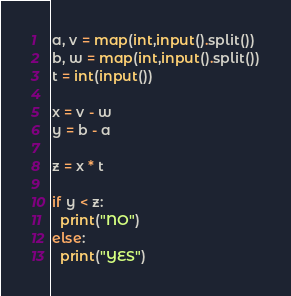<code> <loc_0><loc_0><loc_500><loc_500><_Python_>a, v = map(int,input().split())
b, w = map(int,input().split())
t = int(input())

x = v - w
y = b - a

z = x * t

if y < z:
  print("NO")
else:
  print("YES")


</code> 